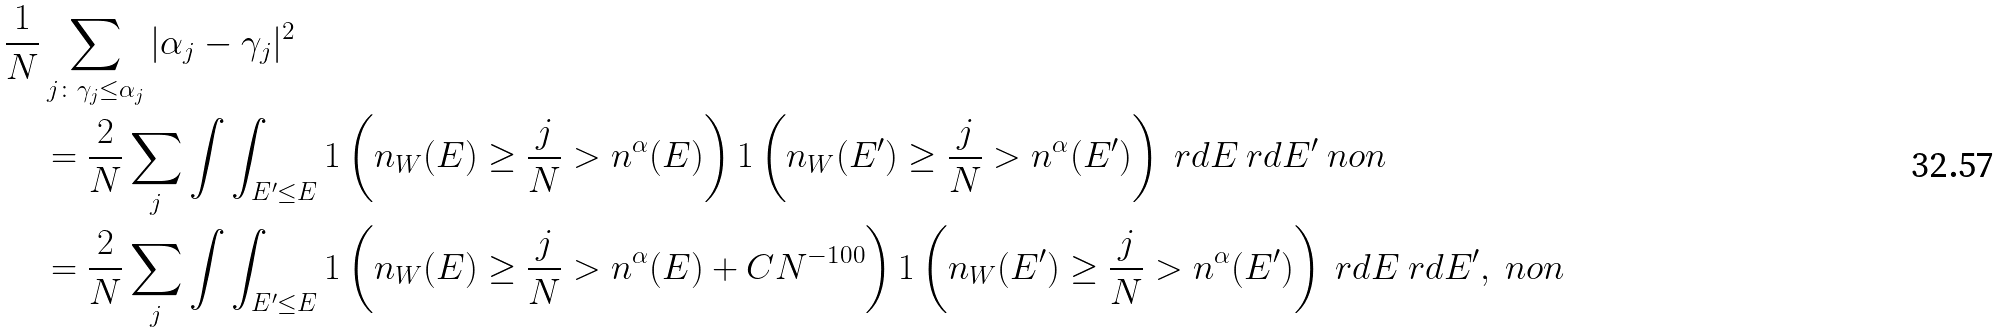<formula> <loc_0><loc_0><loc_500><loc_500>\frac { 1 } { N } & \sum _ { j \colon \gamma _ { j } \leq \alpha _ { j } } | \alpha _ { j } - \gamma _ { j } | ^ { 2 } \\ & = \frac { 2 } { N } \sum _ { j } \int \int _ { E ^ { \prime } \leq E } { 1 } \left ( n _ { W } ( E ) \geq \frac { j } { N } > n ^ { \alpha } ( E ) \right ) { 1 } \left ( n _ { W } ( E ^ { \prime } ) \geq \frac { j } { N } > n ^ { \alpha } ( E ^ { \prime } ) \right ) \ r d E \ r d E ^ { \prime } \ n o n \\ & = \frac { 2 } { N } \sum _ { j } \int \int _ { E ^ { \prime } \leq E } { 1 } \left ( n _ { W } ( E ) \geq \frac { j } { N } > n ^ { \alpha } ( E ) + C N ^ { - 1 0 0 } \right ) { 1 } \left ( n _ { W } ( E ^ { \prime } ) \geq \frac { j } { N } > n ^ { \alpha } ( E ^ { \prime } ) \right ) \ r d E \ r d E ^ { \prime } , \ n o n</formula> 